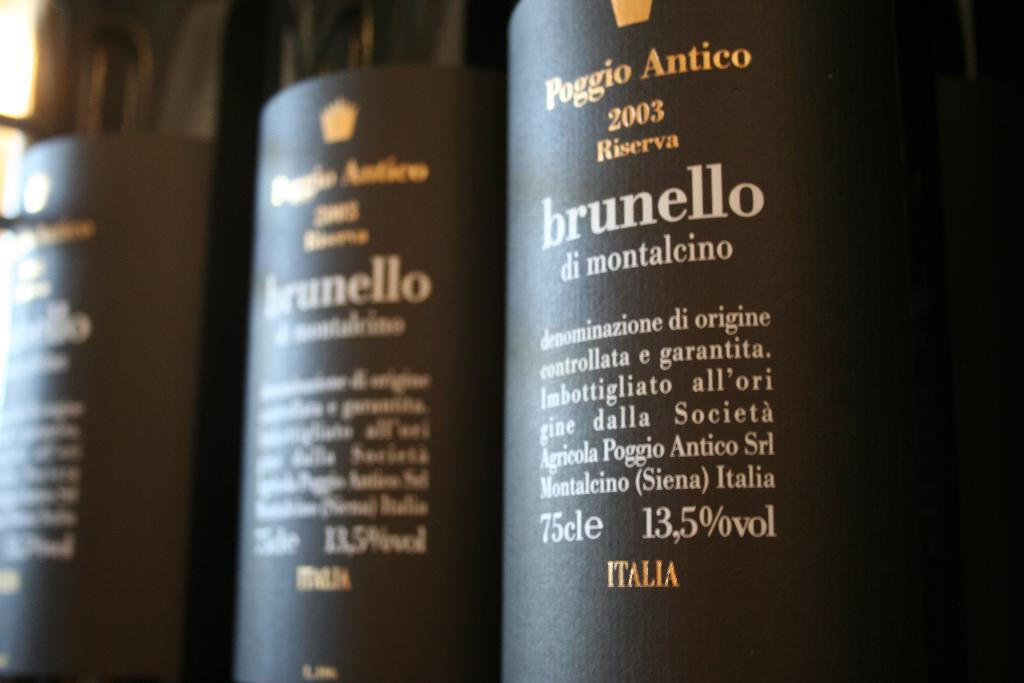<image>
Give a short and clear explanation of the subsequent image. Bottles of Poggio Antico from 2003 are lined up next to each other and contain 13.5% alcohol. 